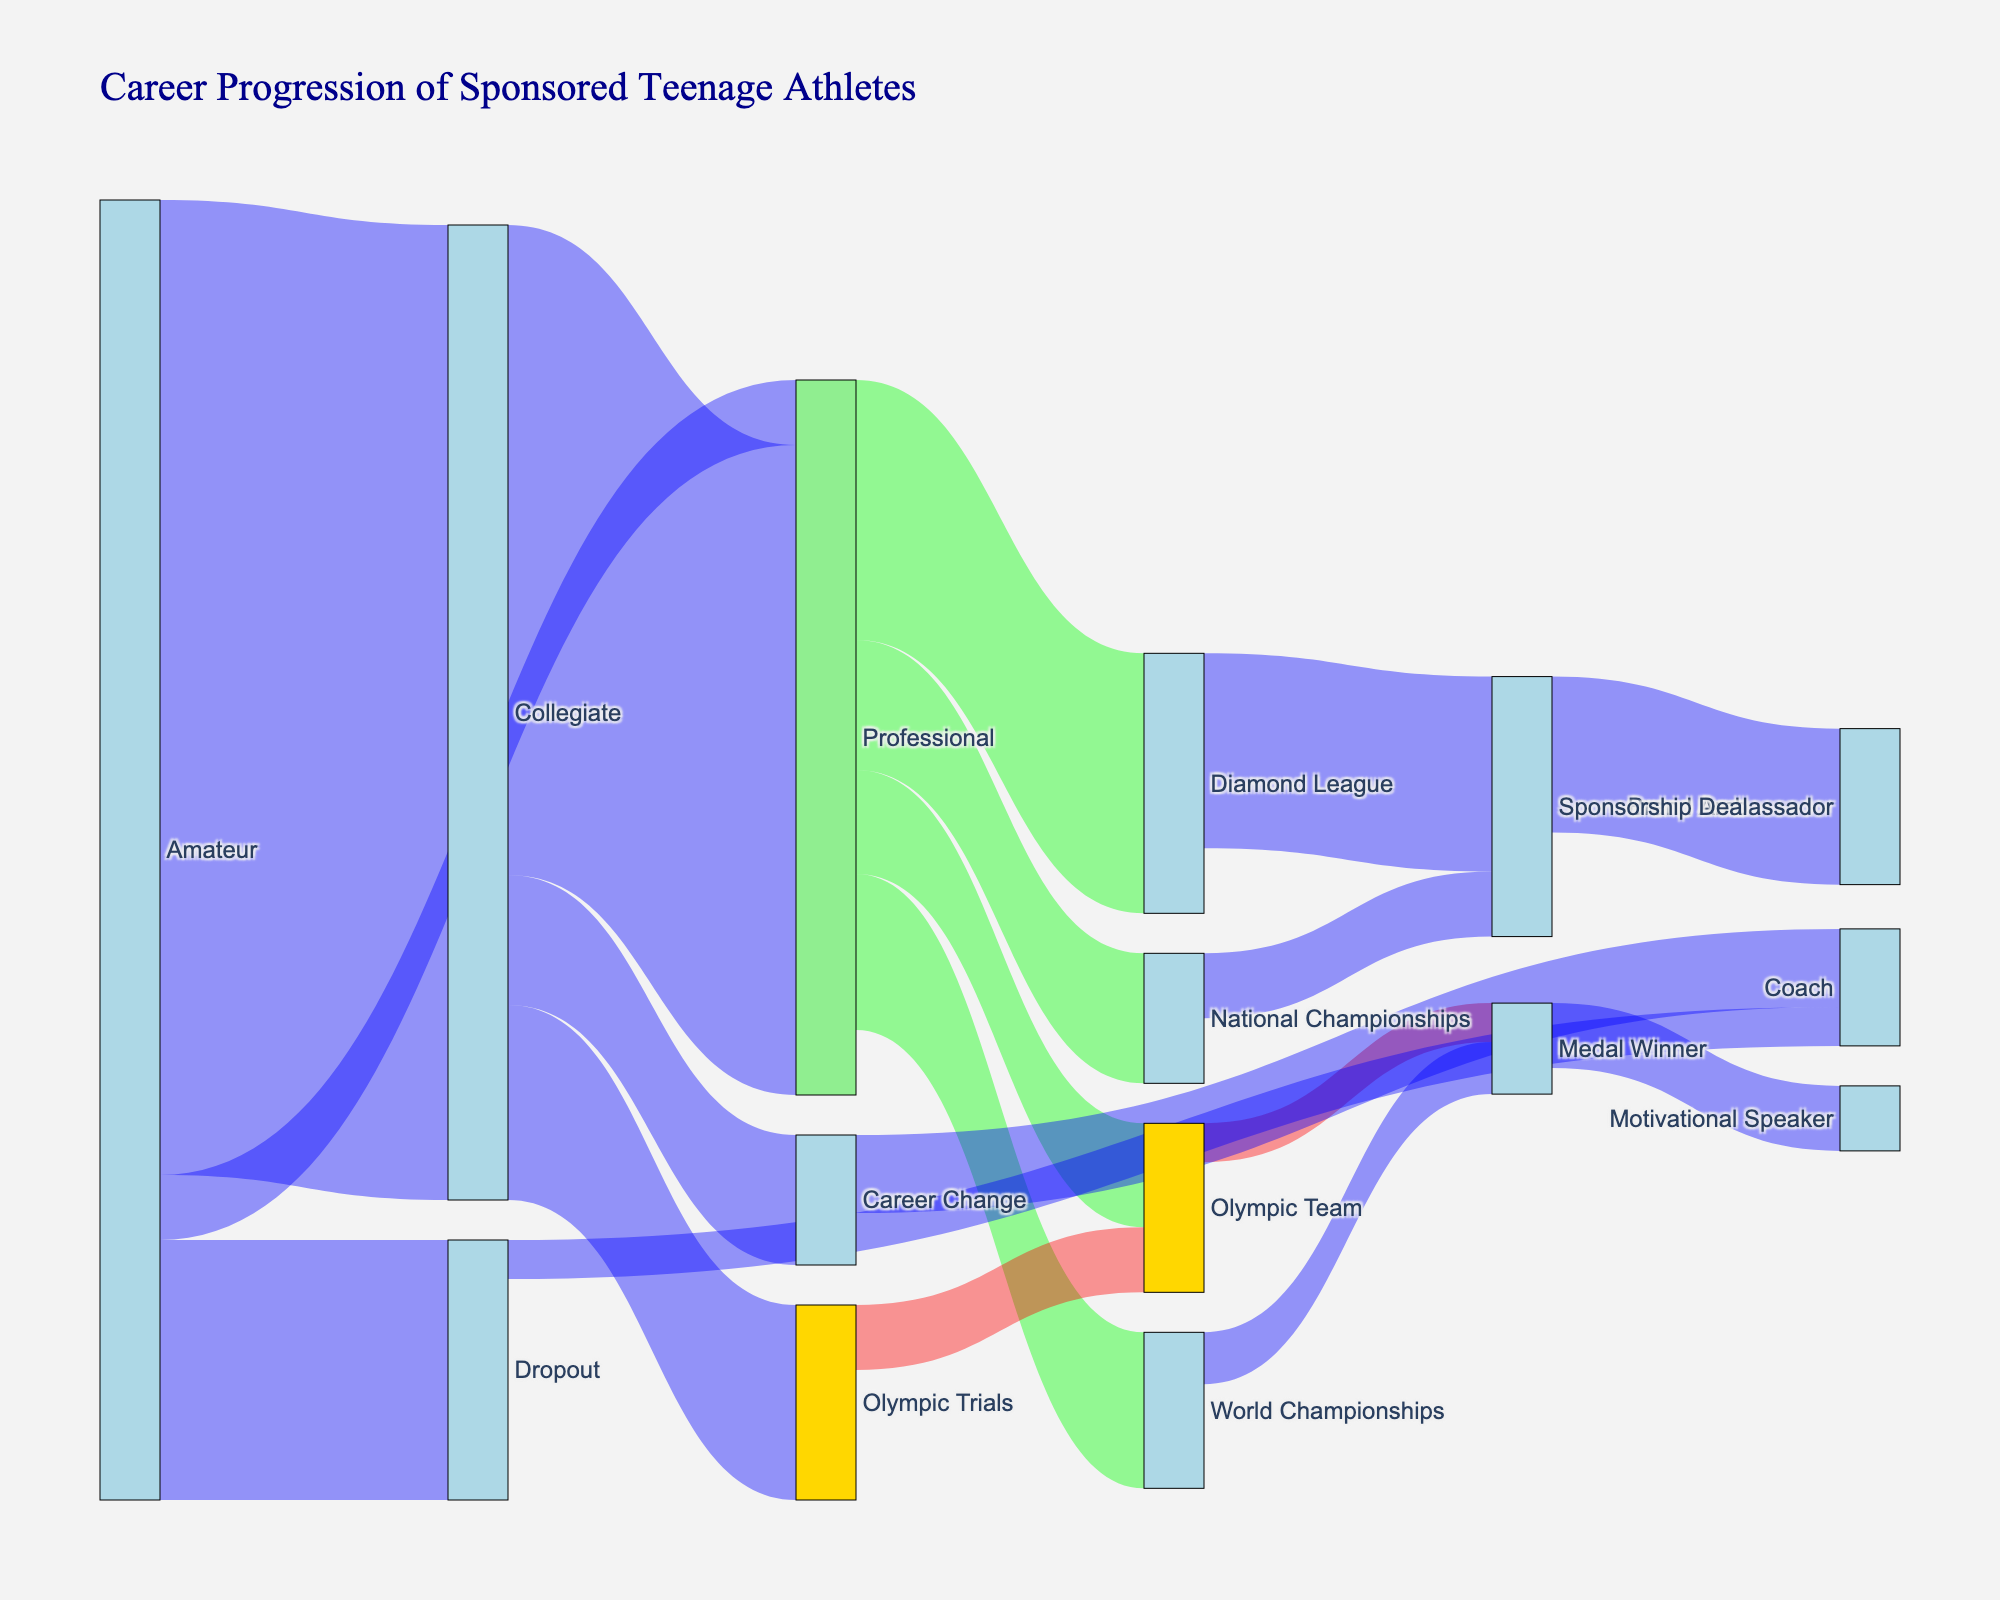What is the total number of athletes who transitioned from Amateur to Collegiate? The figure shows a flow from Amateur to Collegiate with a value attached. Identifying this value tells us the number of athletes.
Answer: 75 How many athletes made it directly from Amateur to Professional level? The figure explicitly displays the transitions with corresponding values. Locate the value connecting Amateur to Professional.
Answer: 5 How many athletes dropped out from the Amateur level? Look at the flow from Amateur to Dropout and find the associated value.
Answer: 20 Which transition has the most number of athletes from the Collegiate level? Review the outgoing transitions from Collegiate and identify the highest value.
Answer: Collegiate to Professional From Professional, which competitive event has the highest number of athletes? Examine professional's connections and find the highest value among Olympic Team, World Championships, Diamond League, and National Championships.
Answer: Diamond League How many athletes reached the Olympic Team from the Professional level? Identify the flow from Professional to Olympic Team and note the value.
Answer: 8 What is the sum of athletes who transitioned to the Sponsorship Deal stage? Sum the values of transitions leading to Sponsorship Deal: Diamond League to Sponsorship Deal and National Championships to Sponsorship Deal.
Answer: 20 Compare the number of athletes who became Medal Winners from the World Championships and the Olympic Team. Which path has more Medal Winners? Look for values connecting Olympic Team to Medal Winner and World Championships to Medal Winner, then compare the values.
Answer: World Championships How many total athletes transitioned out of the Collegiate level? Sum the transition values from Collegiate to Professional, Olympic Trials, and Career Change.
Answer: 75 Which transition chain leads to the role of Motivational Speaker? Trace the flow to Motivational Speaker through intermediate steps. Look for the transition to Medal Winner leading to Motivational Speaker by following the paths step-by-step.
Answer: Medal Winner 